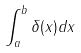Convert formula to latex. <formula><loc_0><loc_0><loc_500><loc_500>\int _ { a } ^ { b } \delta ( x ) d x</formula> 